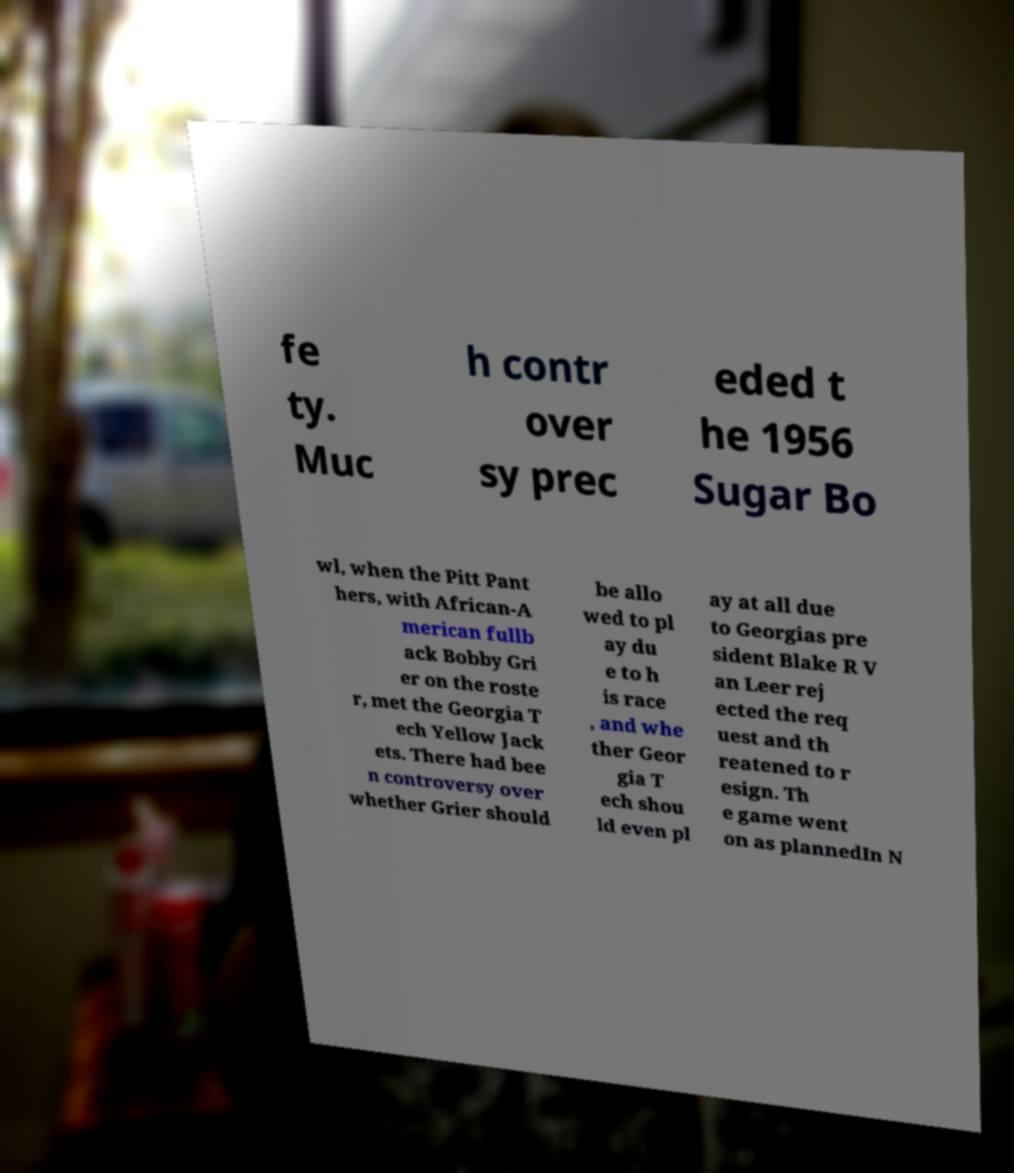There's text embedded in this image that I need extracted. Can you transcribe it verbatim? fe ty. Muc h contr over sy prec eded t he 1956 Sugar Bo wl, when the Pitt Pant hers, with African-A merican fullb ack Bobby Gri er on the roste r, met the Georgia T ech Yellow Jack ets. There had bee n controversy over whether Grier should be allo wed to pl ay du e to h is race , and whe ther Geor gia T ech shou ld even pl ay at all due to Georgias pre sident Blake R V an Leer rej ected the req uest and th reatened to r esign. Th e game went on as plannedIn N 